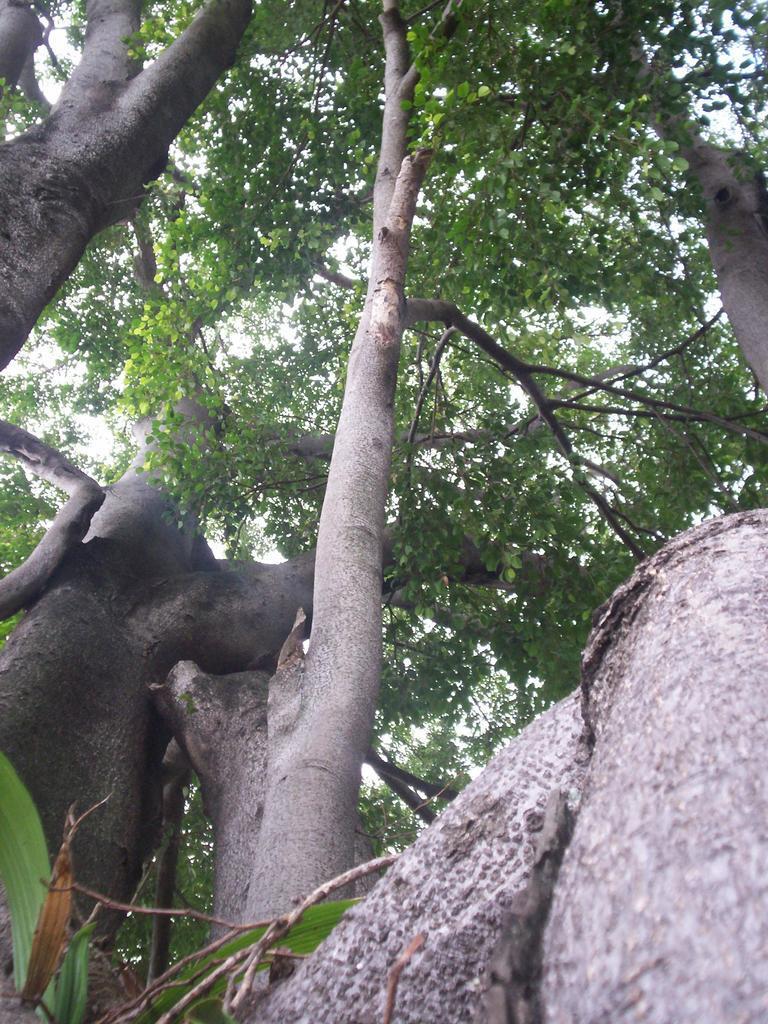Could you give a brief overview of what you see in this image? In this image I can see number of trees. 